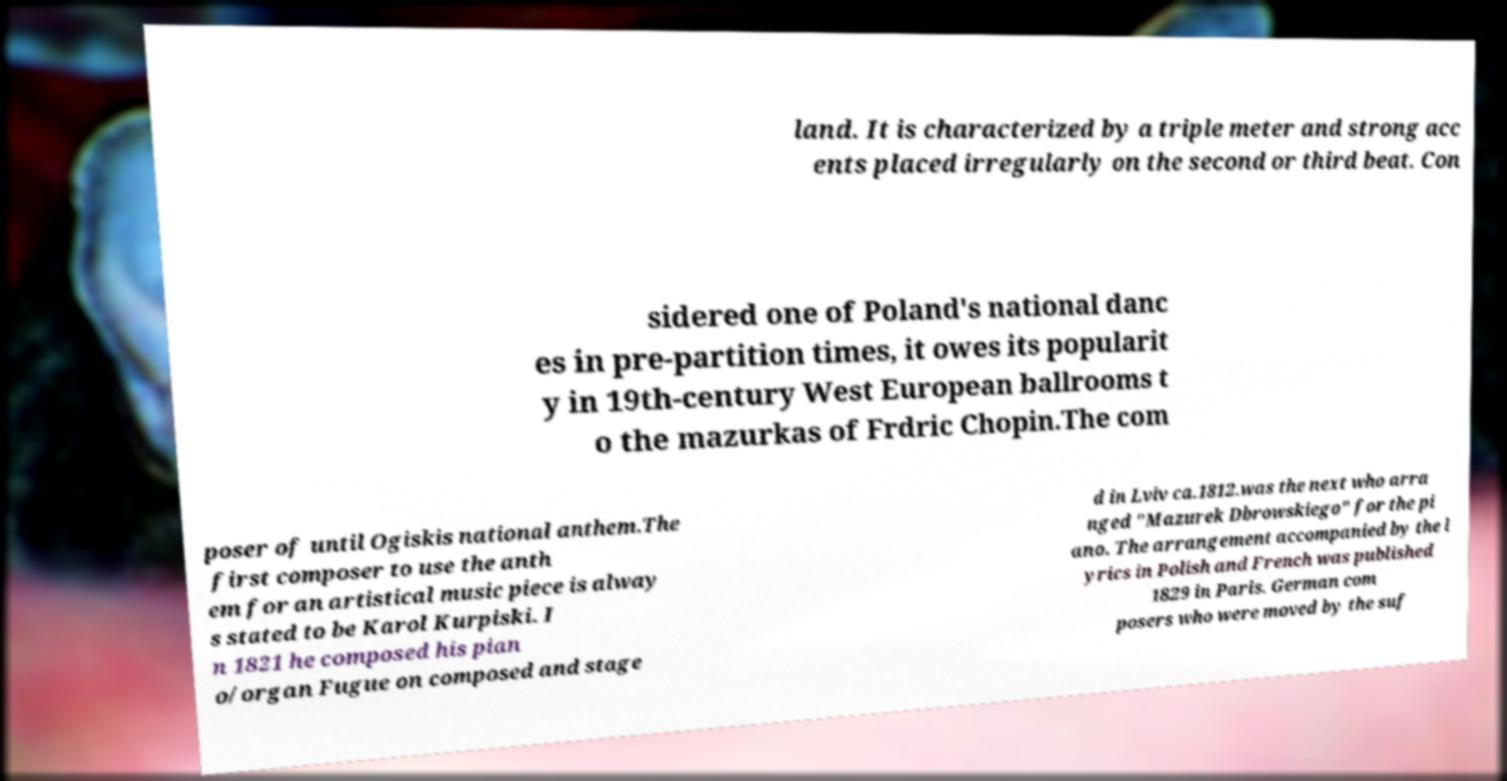I need the written content from this picture converted into text. Can you do that? land. It is characterized by a triple meter and strong acc ents placed irregularly on the second or third beat. Con sidered one of Poland's national danc es in pre-partition times, it owes its popularit y in 19th-century West European ballrooms t o the mazurkas of Frdric Chopin.The com poser of until Ogiskis national anthem.The first composer to use the anth em for an artistical music piece is alway s stated to be Karol Kurpiski. I n 1821 he composed his pian o/organ Fugue on composed and stage d in Lviv ca.1812.was the next who arra nged "Mazurek Dbrowskiego" for the pi ano. The arrangement accompanied by the l yrics in Polish and French was published 1829 in Paris. German com posers who were moved by the suf 